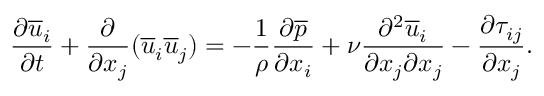<formula> <loc_0><loc_0><loc_500><loc_500>\frac { \partial \overline { u } _ { i } } { \partial t } + \frac { \partial } { \partial x _ { j } } ( \overline { u } _ { i } \overline { u } _ { j } ) = - \frac { 1 } { \rho } \frac { \partial \overline { p } } { \partial x _ { i } } + \nu \frac { \partial ^ { 2 } \overline { u } _ { i } } { \partial x _ { j } \partial x _ { j } } - \frac { \partial \tau _ { i j } } { \partial x _ { j } } .</formula> 